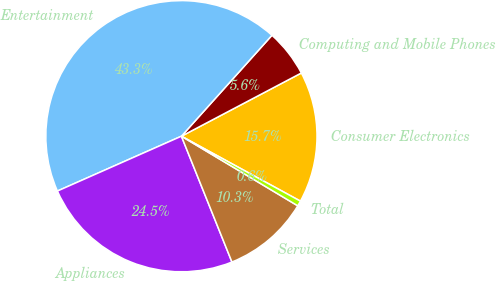Convert chart. <chart><loc_0><loc_0><loc_500><loc_500><pie_chart><fcel>Consumer Electronics<fcel>Computing and Mobile Phones<fcel>Entertainment<fcel>Appliances<fcel>Services<fcel>Total<nl><fcel>15.67%<fcel>5.64%<fcel>43.26%<fcel>24.45%<fcel>10.34%<fcel>0.63%<nl></chart> 